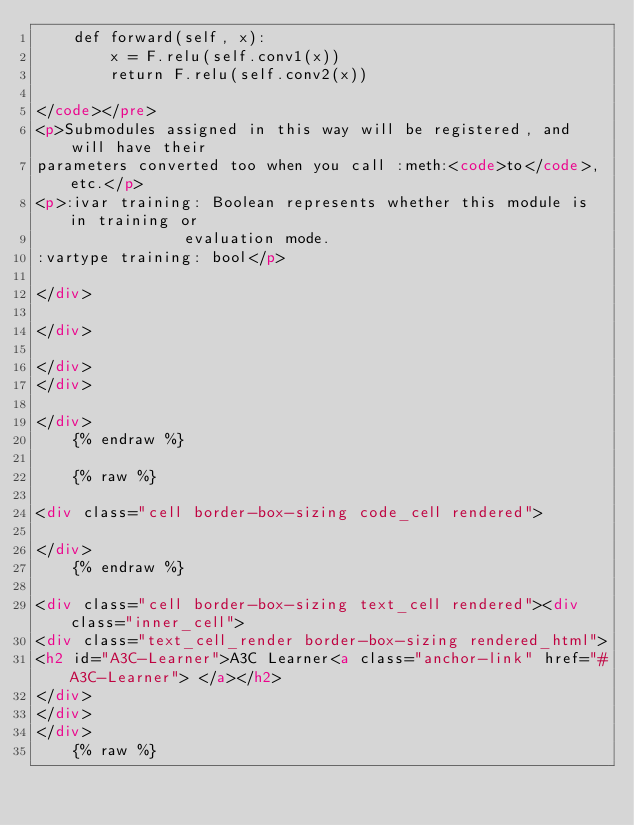<code> <loc_0><loc_0><loc_500><loc_500><_HTML_>    def forward(self, x):
        x = F.relu(self.conv1(x))
        return F.relu(self.conv2(x))

</code></pre>
<p>Submodules assigned in this way will be registered, and will have their
parameters converted too when you call :meth:<code>to</code>, etc.</p>
<p>:ivar training: Boolean represents whether this module is in training or
                evaluation mode.
:vartype training: bool</p>

</div>

</div>

</div>
</div>

</div>
    {% endraw %}

    {% raw %}
    
<div class="cell border-box-sizing code_cell rendered">

</div>
    {% endraw %}

<div class="cell border-box-sizing text_cell rendered"><div class="inner_cell">
<div class="text_cell_render border-box-sizing rendered_html">
<h2 id="A3C-Learner">A3C Learner<a class="anchor-link" href="#A3C-Learner"> </a></h2>
</div>
</div>
</div>
    {% raw %}
    </code> 